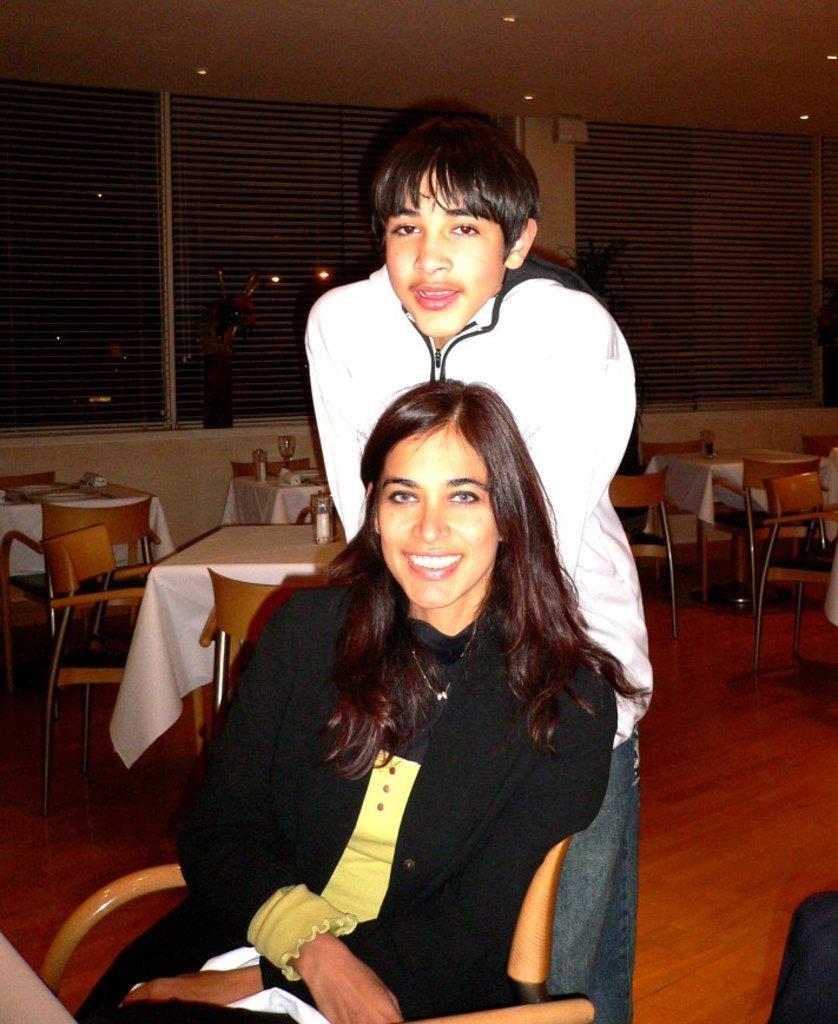Can you describe this image briefly? As we can see in the image there are windows, chairs and tables and two people over here. 